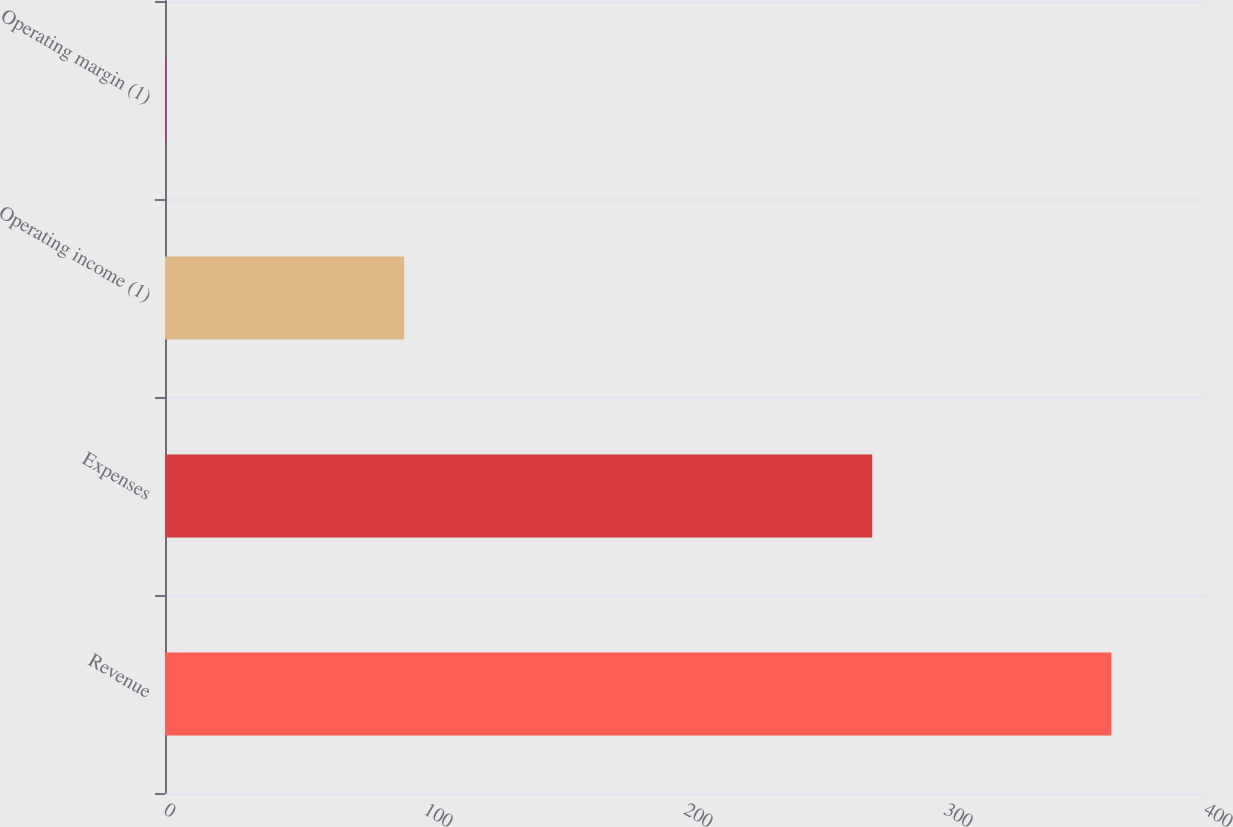Convert chart to OTSL. <chart><loc_0><loc_0><loc_500><loc_500><bar_chart><fcel>Revenue<fcel>Expenses<fcel>Operating income (1)<fcel>Operating margin (1)<nl><fcel>364<fcel>272<fcel>92<fcel>0.5<nl></chart> 